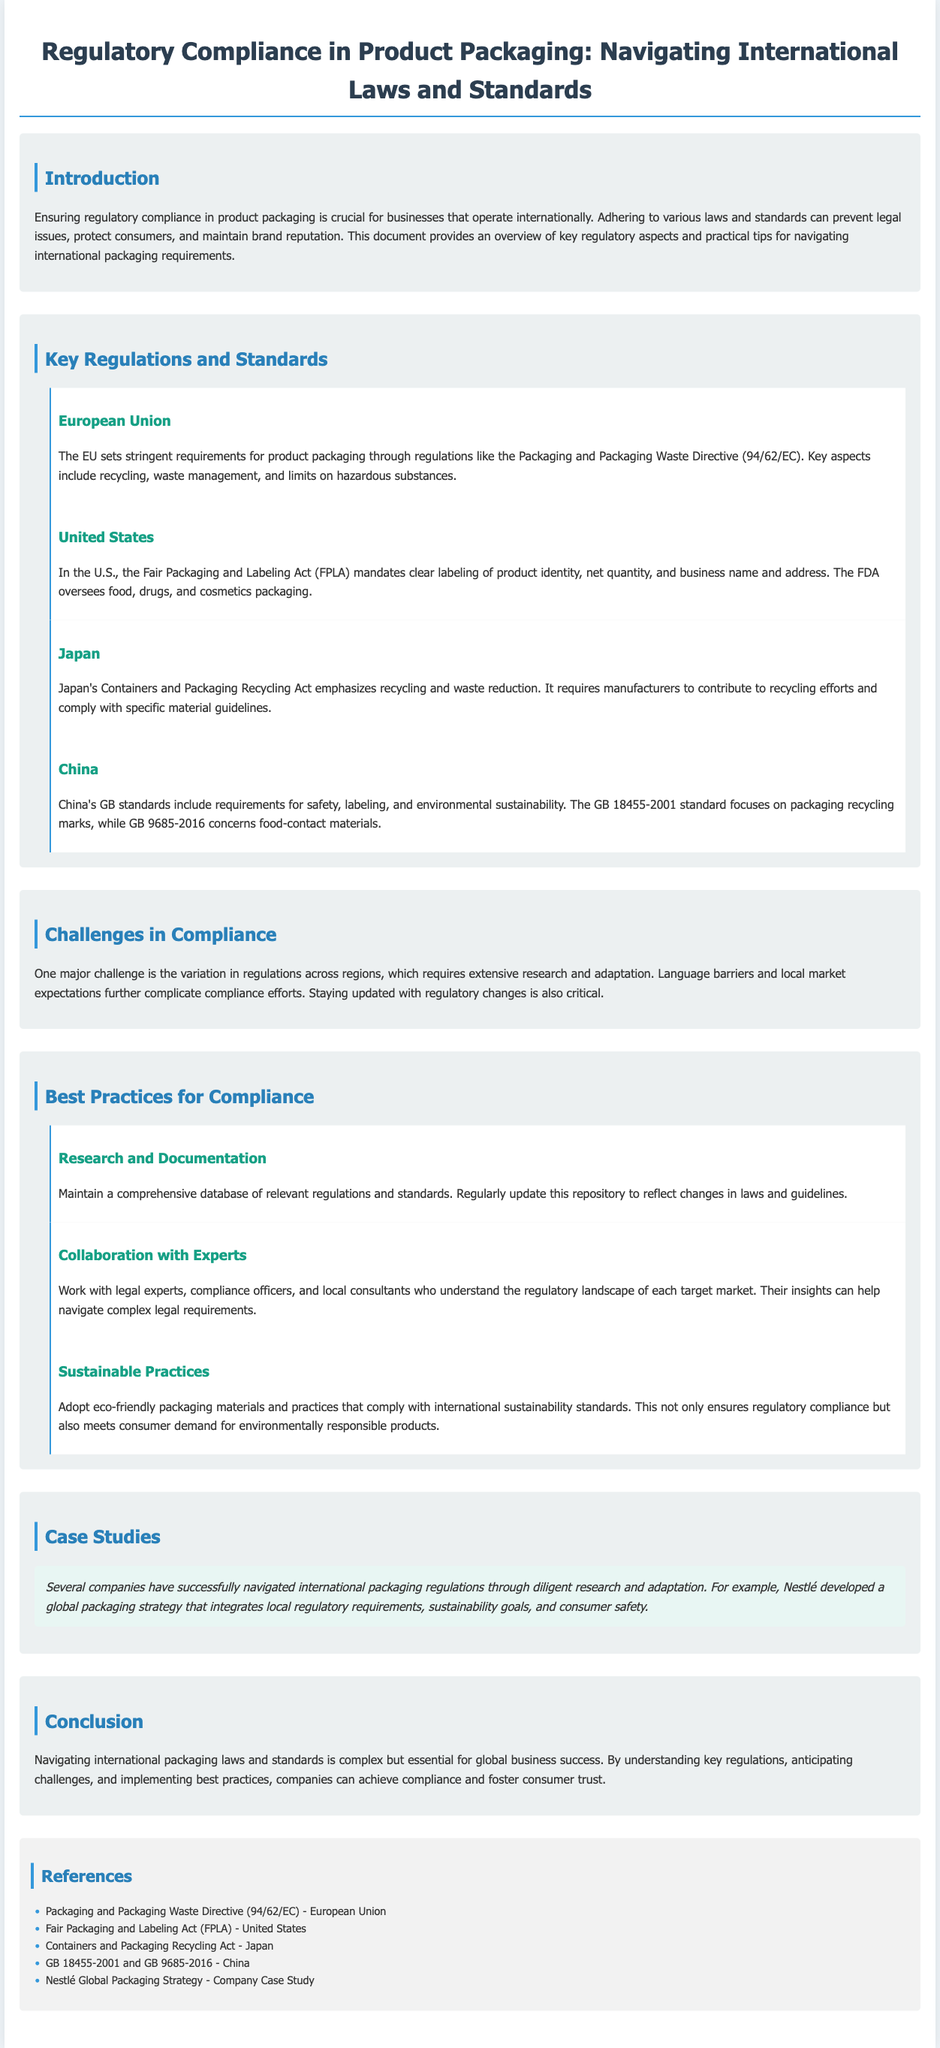What is the title of the document? The title of the document is found in the header section, providing a clear overview of its content.
Answer: Regulatory Compliance in Product Packaging: Navigating International Laws and Standards Which directive governs packaging in the European Union? The document states that the EU has regulations like the Packaging and Packaging Waste Directive for packaging requirements.
Answer: Packaging and Packaging Waste Directive (94/62/EC) What does the U.S. Fair Packaging and Labeling Act mandate? The Act mandates clear labeling of product identity, net quantity, and business name and address as specified in the document.
Answer: Clear labeling What is one challenge in compliance mentioned in the document? The document highlights the variation in regulations across regions as a major challenge in compliance efforts.
Answer: Variation in regulations What is a best practice for compliance regarding regulations and standards? The document suggests maintaining a comprehensive database of relevant regulations as a best practice for compliance.
Answer: Comprehensive database Which country's regulations emphasize recycling and waste reduction? The focus on recycling and waste reduction is highlighted in the section about Japan's legislation.
Answer: Japan How does Nestlé navigate international packaging regulations? The case study mentions that Nestlé developed a global packaging strategy integrating local regulatory requirements.
Answer: Global packaging strategy What is a key aspect of China's GB standards? The document outlines that China's GB standards include requirements for safety, labeling, and environmental sustainability.
Answer: Safety, labeling, and environmental sustainability 